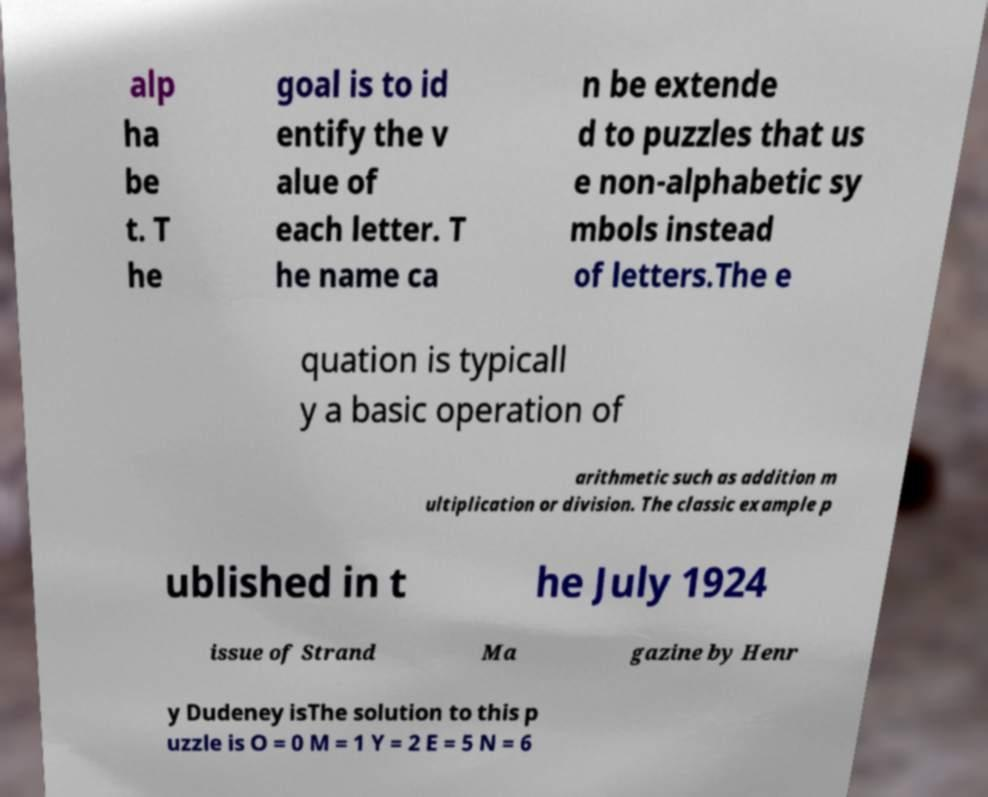What messages or text are displayed in this image? I need them in a readable, typed format. alp ha be t. T he goal is to id entify the v alue of each letter. T he name ca n be extende d to puzzles that us e non-alphabetic sy mbols instead of letters.The e quation is typicall y a basic operation of arithmetic such as addition m ultiplication or division. The classic example p ublished in t he July 1924 issue of Strand Ma gazine by Henr y Dudeney isThe solution to this p uzzle is O = 0 M = 1 Y = 2 E = 5 N = 6 